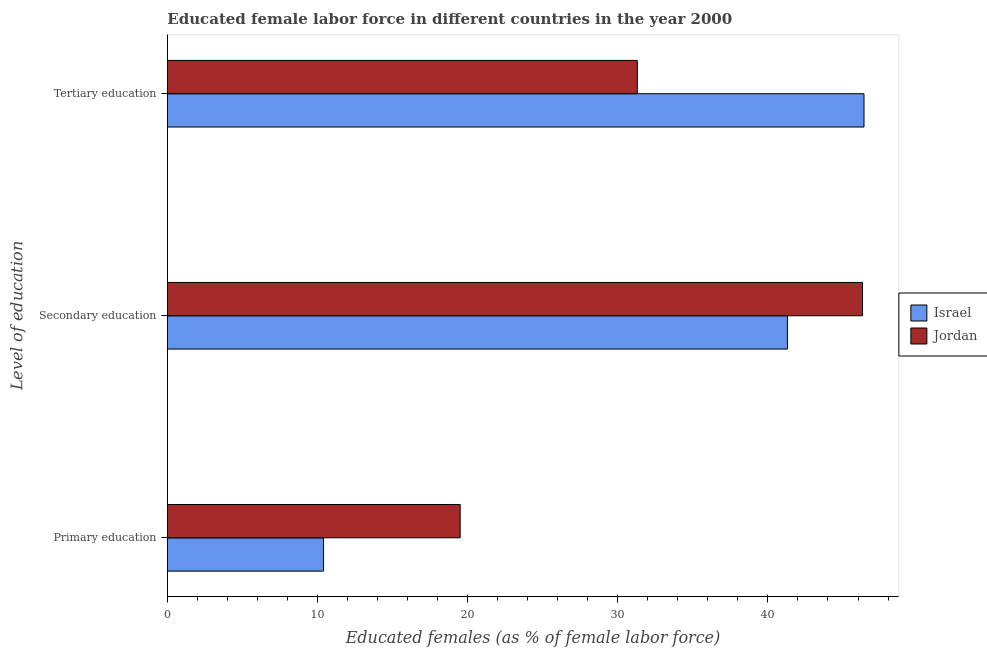How many different coloured bars are there?
Make the answer very short. 2. How many bars are there on the 2nd tick from the bottom?
Your answer should be compact. 2. What is the label of the 2nd group of bars from the top?
Give a very brief answer. Secondary education. What is the percentage of female labor force who received secondary education in Jordan?
Your response must be concise. 46.3. Across all countries, what is the maximum percentage of female labor force who received tertiary education?
Offer a very short reply. 46.4. Across all countries, what is the minimum percentage of female labor force who received secondary education?
Make the answer very short. 41.3. In which country was the percentage of female labor force who received tertiary education maximum?
Offer a terse response. Israel. What is the total percentage of female labor force who received secondary education in the graph?
Your answer should be very brief. 87.6. What is the difference between the percentage of female labor force who received tertiary education in Israel and that in Jordan?
Provide a short and direct response. 15.1. What is the difference between the percentage of female labor force who received tertiary education in Jordan and the percentage of female labor force who received secondary education in Israel?
Your answer should be compact. -10. What is the average percentage of female labor force who received tertiary education per country?
Give a very brief answer. 38.85. What is the difference between the percentage of female labor force who received secondary education and percentage of female labor force who received primary education in Jordan?
Give a very brief answer. 26.8. What is the ratio of the percentage of female labor force who received primary education in Israel to that in Jordan?
Provide a short and direct response. 0.53. Is the percentage of female labor force who received primary education in Jordan less than that in Israel?
Give a very brief answer. No. Is the difference between the percentage of female labor force who received tertiary education in Jordan and Israel greater than the difference between the percentage of female labor force who received secondary education in Jordan and Israel?
Your response must be concise. No. What is the difference between the highest and the lowest percentage of female labor force who received primary education?
Offer a very short reply. 9.1. In how many countries, is the percentage of female labor force who received secondary education greater than the average percentage of female labor force who received secondary education taken over all countries?
Offer a terse response. 1. Is the sum of the percentage of female labor force who received primary education in Israel and Jordan greater than the maximum percentage of female labor force who received tertiary education across all countries?
Your answer should be compact. No. What does the 2nd bar from the bottom in Primary education represents?
Make the answer very short. Jordan. Is it the case that in every country, the sum of the percentage of female labor force who received primary education and percentage of female labor force who received secondary education is greater than the percentage of female labor force who received tertiary education?
Your answer should be very brief. Yes. Are the values on the major ticks of X-axis written in scientific E-notation?
Ensure brevity in your answer.  No. Does the graph contain grids?
Your answer should be very brief. No. Where does the legend appear in the graph?
Make the answer very short. Center right. How many legend labels are there?
Give a very brief answer. 2. What is the title of the graph?
Your answer should be compact. Educated female labor force in different countries in the year 2000. What is the label or title of the X-axis?
Give a very brief answer. Educated females (as % of female labor force). What is the label or title of the Y-axis?
Offer a terse response. Level of education. What is the Educated females (as % of female labor force) of Israel in Primary education?
Offer a very short reply. 10.4. What is the Educated females (as % of female labor force) in Israel in Secondary education?
Provide a short and direct response. 41.3. What is the Educated females (as % of female labor force) in Jordan in Secondary education?
Provide a succinct answer. 46.3. What is the Educated females (as % of female labor force) in Israel in Tertiary education?
Offer a terse response. 46.4. What is the Educated females (as % of female labor force) in Jordan in Tertiary education?
Give a very brief answer. 31.3. Across all Level of education, what is the maximum Educated females (as % of female labor force) in Israel?
Your answer should be very brief. 46.4. Across all Level of education, what is the maximum Educated females (as % of female labor force) of Jordan?
Give a very brief answer. 46.3. Across all Level of education, what is the minimum Educated females (as % of female labor force) in Israel?
Your answer should be compact. 10.4. Across all Level of education, what is the minimum Educated females (as % of female labor force) of Jordan?
Offer a terse response. 19.5. What is the total Educated females (as % of female labor force) of Israel in the graph?
Give a very brief answer. 98.1. What is the total Educated females (as % of female labor force) of Jordan in the graph?
Your response must be concise. 97.1. What is the difference between the Educated females (as % of female labor force) in Israel in Primary education and that in Secondary education?
Make the answer very short. -30.9. What is the difference between the Educated females (as % of female labor force) in Jordan in Primary education and that in Secondary education?
Keep it short and to the point. -26.8. What is the difference between the Educated females (as % of female labor force) in Israel in Primary education and that in Tertiary education?
Provide a succinct answer. -36. What is the difference between the Educated females (as % of female labor force) in Jordan in Secondary education and that in Tertiary education?
Your answer should be very brief. 15. What is the difference between the Educated females (as % of female labor force) of Israel in Primary education and the Educated females (as % of female labor force) of Jordan in Secondary education?
Give a very brief answer. -35.9. What is the difference between the Educated females (as % of female labor force) in Israel in Primary education and the Educated females (as % of female labor force) in Jordan in Tertiary education?
Make the answer very short. -20.9. What is the average Educated females (as % of female labor force) of Israel per Level of education?
Offer a terse response. 32.7. What is the average Educated females (as % of female labor force) of Jordan per Level of education?
Ensure brevity in your answer.  32.37. What is the difference between the Educated females (as % of female labor force) in Israel and Educated females (as % of female labor force) in Jordan in Secondary education?
Ensure brevity in your answer.  -5. What is the ratio of the Educated females (as % of female labor force) in Israel in Primary education to that in Secondary education?
Provide a short and direct response. 0.25. What is the ratio of the Educated females (as % of female labor force) of Jordan in Primary education to that in Secondary education?
Make the answer very short. 0.42. What is the ratio of the Educated females (as % of female labor force) of Israel in Primary education to that in Tertiary education?
Provide a succinct answer. 0.22. What is the ratio of the Educated females (as % of female labor force) in Jordan in Primary education to that in Tertiary education?
Your response must be concise. 0.62. What is the ratio of the Educated females (as % of female labor force) in Israel in Secondary education to that in Tertiary education?
Your response must be concise. 0.89. What is the ratio of the Educated females (as % of female labor force) in Jordan in Secondary education to that in Tertiary education?
Provide a succinct answer. 1.48. What is the difference between the highest and the second highest Educated females (as % of female labor force) in Jordan?
Give a very brief answer. 15. What is the difference between the highest and the lowest Educated females (as % of female labor force) in Jordan?
Your answer should be very brief. 26.8. 